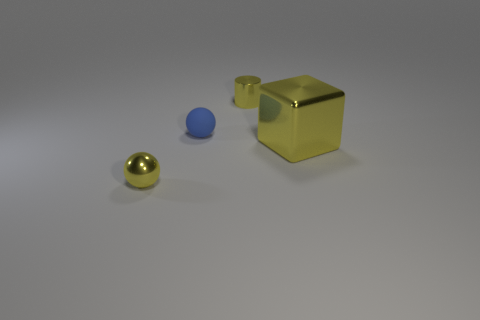What number of metal things are red spheres or large objects?
Give a very brief answer. 1. How many tiny things are both left of the blue thing and behind the cube?
Your answer should be compact. 0. Are there any other things that have the same shape as the big yellow object?
Your answer should be very brief. No. What number of other objects are the same size as the yellow shiny cube?
Provide a succinct answer. 0. Does the yellow thing that is to the left of the tiny blue thing have the same size as the thing that is behind the small rubber object?
Give a very brief answer. Yes. What number of objects are either brown rubber cylinders or spheres that are right of the small yellow metallic sphere?
Provide a succinct answer. 1. What size is the shiny cube on the right side of the blue matte thing?
Provide a succinct answer. Large. Are there fewer tiny balls right of the small blue object than large yellow things that are behind the yellow ball?
Provide a short and direct response. Yes. The tiny object that is both in front of the tiny yellow metallic cylinder and behind the big yellow cube is made of what material?
Keep it short and to the point. Rubber. The yellow metallic thing on the left side of the shiny object behind the blue rubber thing is what shape?
Provide a short and direct response. Sphere. 